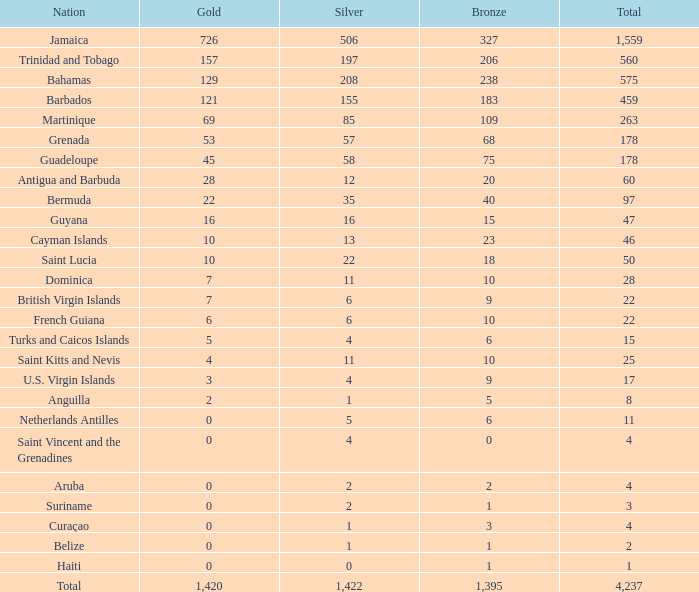Could you parse the entire table as a dict? {'header': ['Nation', 'Gold', 'Silver', 'Bronze', 'Total'], 'rows': [['Jamaica', '726', '506', '327', '1,559'], ['Trinidad and Tobago', '157', '197', '206', '560'], ['Bahamas', '129', '208', '238', '575'], ['Barbados', '121', '155', '183', '459'], ['Martinique', '69', '85', '109', '263'], ['Grenada', '53', '57', '68', '178'], ['Guadeloupe', '45', '58', '75', '178'], ['Antigua and Barbuda', '28', '12', '20', '60'], ['Bermuda', '22', '35', '40', '97'], ['Guyana', '16', '16', '15', '47'], ['Cayman Islands', '10', '13', '23', '46'], ['Saint Lucia', '10', '22', '18', '50'], ['Dominica', '7', '11', '10', '28'], ['British Virgin Islands', '7', '6', '9', '22'], ['French Guiana', '6', '6', '10', '22'], ['Turks and Caicos Islands', '5', '4', '6', '15'], ['Saint Kitts and Nevis', '4', '11', '10', '25'], ['U.S. Virgin Islands', '3', '4', '9', '17'], ['Anguilla', '2', '1', '5', '8'], ['Netherlands Antilles', '0', '5', '6', '11'], ['Saint Vincent and the Grenadines', '0', '4', '0', '4'], ['Aruba', '0', '2', '2', '4'], ['Suriname', '0', '2', '1', '3'], ['Curaçao', '0', '1', '3', '4'], ['Belize', '0', '1', '1', '2'], ['Haiti', '0', '0', '1', '1'], ['Total', '1,420', '1,422', '1,395', '4,237']]} What is the aggregate number of silver having gold more than 0, bronze below 23, a total above 22, and the nation associated with saint kitts and nevis? 1.0. 